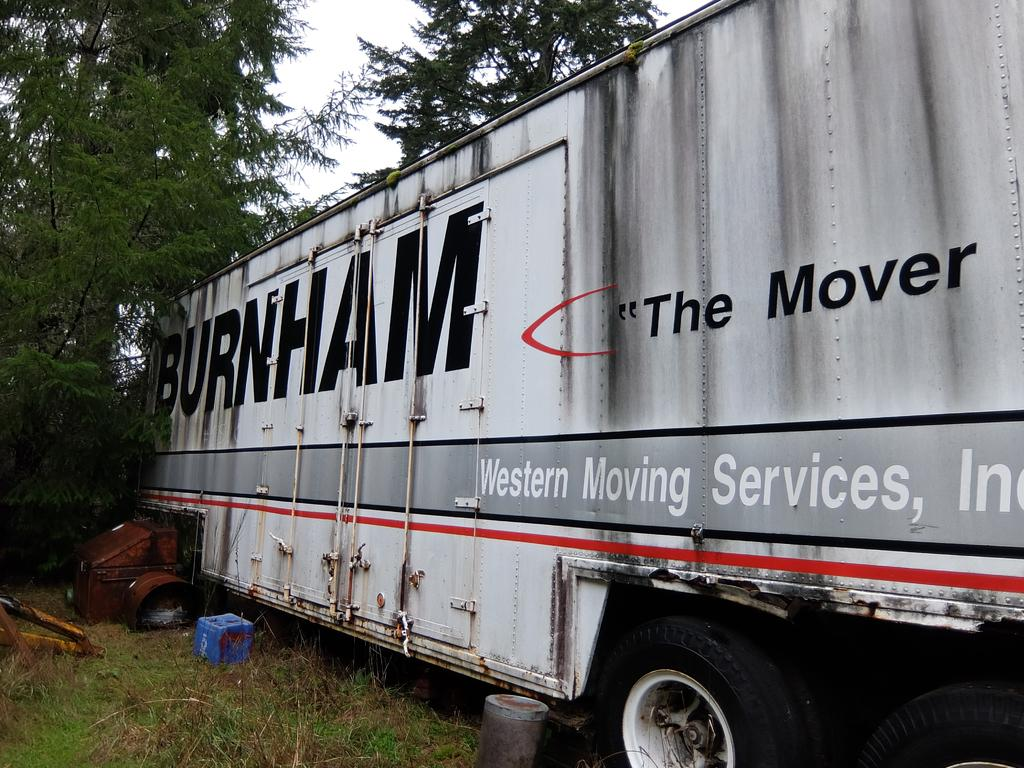What is the main subject of the image? The main subject of the image is a truck. Can you describe the truck in the image? The truck is white and is located in the middle of the image. What else can be seen in the image besides the truck? Trees and the sky are visible in the image. How many goldfish are swimming in the yard in the image? There are no goldfish or yards present in the image; it features a white truck in the middle of the scene with trees and the sky visible. 